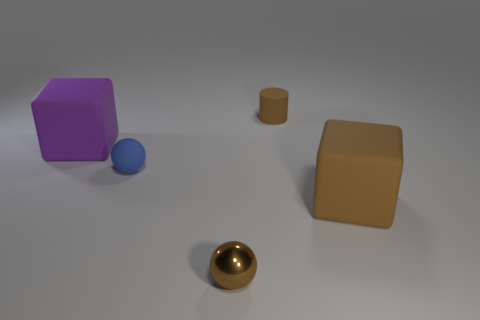Add 5 cyan things. How many objects exist? 10 Subtract all balls. How many objects are left? 3 Subtract 0 purple balls. How many objects are left? 5 Subtract all red metal objects. Subtract all brown cylinders. How many objects are left? 4 Add 3 small brown metallic spheres. How many small brown metallic spheres are left? 4 Add 2 big cyan spheres. How many big cyan spheres exist? 2 